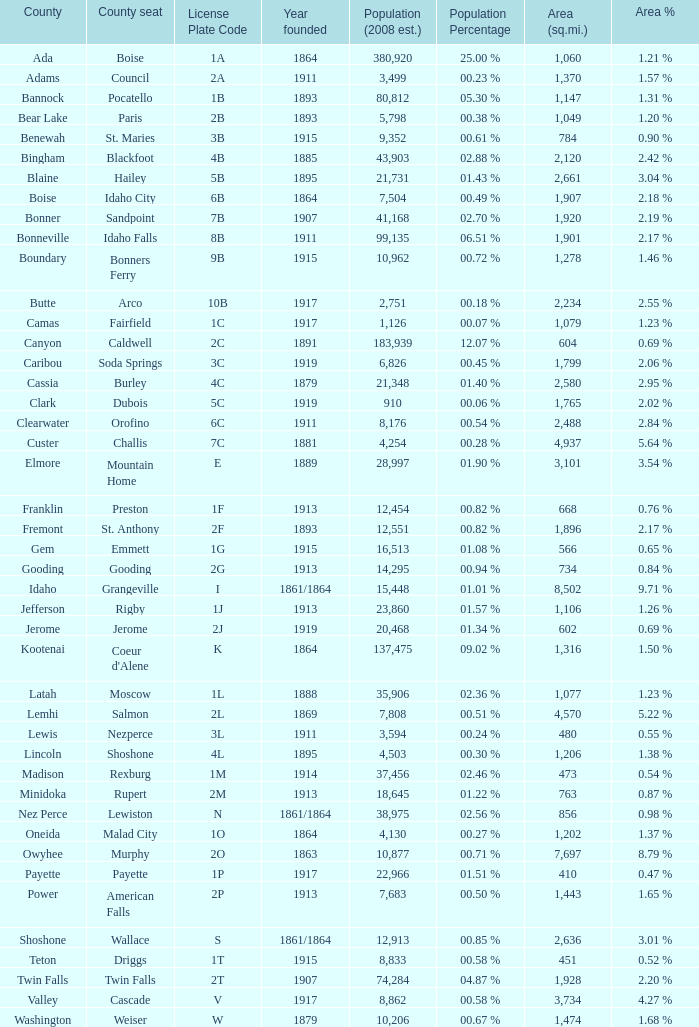What is the country seat for the license plate code 5c? Dubois. 